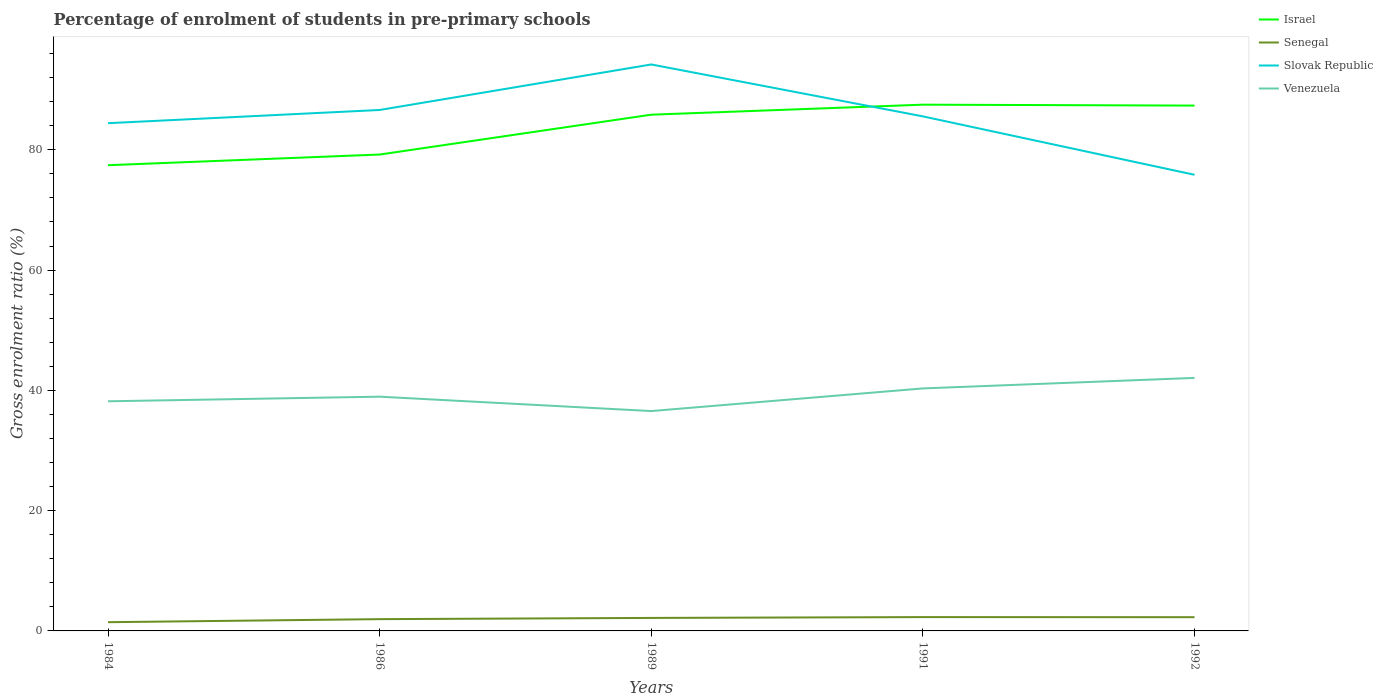How many different coloured lines are there?
Your answer should be very brief. 4. Does the line corresponding to Venezuela intersect with the line corresponding to Slovak Republic?
Offer a terse response. No. Across all years, what is the maximum percentage of students enrolled in pre-primary schools in Israel?
Offer a terse response. 77.43. What is the total percentage of students enrolled in pre-primary schools in Slovak Republic in the graph?
Give a very brief answer. 1.07. What is the difference between the highest and the second highest percentage of students enrolled in pre-primary schools in Venezuela?
Give a very brief answer. 5.51. What is the difference between the highest and the lowest percentage of students enrolled in pre-primary schools in Israel?
Keep it short and to the point. 3. Is the percentage of students enrolled in pre-primary schools in Slovak Republic strictly greater than the percentage of students enrolled in pre-primary schools in Venezuela over the years?
Offer a terse response. No. What is the difference between two consecutive major ticks on the Y-axis?
Provide a short and direct response. 20. Does the graph contain any zero values?
Keep it short and to the point. No. Where does the legend appear in the graph?
Keep it short and to the point. Top right. How many legend labels are there?
Your answer should be very brief. 4. What is the title of the graph?
Keep it short and to the point. Percentage of enrolment of students in pre-primary schools. What is the label or title of the Y-axis?
Ensure brevity in your answer.  Gross enrolment ratio (%). What is the Gross enrolment ratio (%) in Israel in 1984?
Offer a terse response. 77.43. What is the Gross enrolment ratio (%) of Senegal in 1984?
Your answer should be compact. 1.45. What is the Gross enrolment ratio (%) of Slovak Republic in 1984?
Offer a very short reply. 84.42. What is the Gross enrolment ratio (%) in Venezuela in 1984?
Make the answer very short. 38.18. What is the Gross enrolment ratio (%) in Israel in 1986?
Ensure brevity in your answer.  79.21. What is the Gross enrolment ratio (%) of Senegal in 1986?
Offer a very short reply. 1.96. What is the Gross enrolment ratio (%) of Slovak Republic in 1986?
Keep it short and to the point. 86.62. What is the Gross enrolment ratio (%) in Venezuela in 1986?
Offer a terse response. 38.95. What is the Gross enrolment ratio (%) of Israel in 1989?
Give a very brief answer. 85.83. What is the Gross enrolment ratio (%) in Senegal in 1989?
Offer a terse response. 2.16. What is the Gross enrolment ratio (%) of Slovak Republic in 1989?
Keep it short and to the point. 94.18. What is the Gross enrolment ratio (%) in Venezuela in 1989?
Keep it short and to the point. 36.56. What is the Gross enrolment ratio (%) in Israel in 1991?
Keep it short and to the point. 87.5. What is the Gross enrolment ratio (%) of Senegal in 1991?
Provide a succinct answer. 2.3. What is the Gross enrolment ratio (%) of Slovak Republic in 1991?
Provide a succinct answer. 85.55. What is the Gross enrolment ratio (%) in Venezuela in 1991?
Your answer should be compact. 40.32. What is the Gross enrolment ratio (%) of Israel in 1992?
Your answer should be compact. 87.35. What is the Gross enrolment ratio (%) in Senegal in 1992?
Ensure brevity in your answer.  2.28. What is the Gross enrolment ratio (%) of Slovak Republic in 1992?
Make the answer very short. 75.84. What is the Gross enrolment ratio (%) of Venezuela in 1992?
Offer a very short reply. 42.07. Across all years, what is the maximum Gross enrolment ratio (%) in Israel?
Offer a terse response. 87.5. Across all years, what is the maximum Gross enrolment ratio (%) in Senegal?
Make the answer very short. 2.3. Across all years, what is the maximum Gross enrolment ratio (%) in Slovak Republic?
Offer a terse response. 94.18. Across all years, what is the maximum Gross enrolment ratio (%) in Venezuela?
Make the answer very short. 42.07. Across all years, what is the minimum Gross enrolment ratio (%) in Israel?
Provide a succinct answer. 77.43. Across all years, what is the minimum Gross enrolment ratio (%) of Senegal?
Your response must be concise. 1.45. Across all years, what is the minimum Gross enrolment ratio (%) in Slovak Republic?
Your response must be concise. 75.84. Across all years, what is the minimum Gross enrolment ratio (%) in Venezuela?
Your answer should be very brief. 36.56. What is the total Gross enrolment ratio (%) of Israel in the graph?
Ensure brevity in your answer.  417.32. What is the total Gross enrolment ratio (%) of Senegal in the graph?
Your answer should be very brief. 10.15. What is the total Gross enrolment ratio (%) of Slovak Republic in the graph?
Your answer should be compact. 426.62. What is the total Gross enrolment ratio (%) in Venezuela in the graph?
Your answer should be very brief. 196.07. What is the difference between the Gross enrolment ratio (%) in Israel in 1984 and that in 1986?
Your answer should be very brief. -1.77. What is the difference between the Gross enrolment ratio (%) in Senegal in 1984 and that in 1986?
Offer a terse response. -0.51. What is the difference between the Gross enrolment ratio (%) in Slovak Republic in 1984 and that in 1986?
Offer a very short reply. -2.2. What is the difference between the Gross enrolment ratio (%) of Venezuela in 1984 and that in 1986?
Your response must be concise. -0.77. What is the difference between the Gross enrolment ratio (%) in Israel in 1984 and that in 1989?
Give a very brief answer. -8.4. What is the difference between the Gross enrolment ratio (%) in Senegal in 1984 and that in 1989?
Ensure brevity in your answer.  -0.71. What is the difference between the Gross enrolment ratio (%) of Slovak Republic in 1984 and that in 1989?
Offer a terse response. -9.76. What is the difference between the Gross enrolment ratio (%) in Venezuela in 1984 and that in 1989?
Provide a succinct answer. 1.62. What is the difference between the Gross enrolment ratio (%) of Israel in 1984 and that in 1991?
Offer a very short reply. -10.06. What is the difference between the Gross enrolment ratio (%) in Senegal in 1984 and that in 1991?
Make the answer very short. -0.85. What is the difference between the Gross enrolment ratio (%) of Slovak Republic in 1984 and that in 1991?
Offer a very short reply. -1.13. What is the difference between the Gross enrolment ratio (%) of Venezuela in 1984 and that in 1991?
Offer a very short reply. -2.14. What is the difference between the Gross enrolment ratio (%) of Israel in 1984 and that in 1992?
Keep it short and to the point. -9.91. What is the difference between the Gross enrolment ratio (%) of Senegal in 1984 and that in 1992?
Ensure brevity in your answer.  -0.83. What is the difference between the Gross enrolment ratio (%) in Slovak Republic in 1984 and that in 1992?
Make the answer very short. 8.58. What is the difference between the Gross enrolment ratio (%) of Venezuela in 1984 and that in 1992?
Give a very brief answer. -3.89. What is the difference between the Gross enrolment ratio (%) in Israel in 1986 and that in 1989?
Your answer should be very brief. -6.63. What is the difference between the Gross enrolment ratio (%) in Senegal in 1986 and that in 1989?
Keep it short and to the point. -0.2. What is the difference between the Gross enrolment ratio (%) of Slovak Republic in 1986 and that in 1989?
Provide a succinct answer. -7.57. What is the difference between the Gross enrolment ratio (%) of Venezuela in 1986 and that in 1989?
Make the answer very short. 2.39. What is the difference between the Gross enrolment ratio (%) in Israel in 1986 and that in 1991?
Your answer should be very brief. -8.29. What is the difference between the Gross enrolment ratio (%) in Senegal in 1986 and that in 1991?
Make the answer very short. -0.34. What is the difference between the Gross enrolment ratio (%) in Slovak Republic in 1986 and that in 1991?
Provide a short and direct response. 1.07. What is the difference between the Gross enrolment ratio (%) of Venezuela in 1986 and that in 1991?
Your answer should be compact. -1.37. What is the difference between the Gross enrolment ratio (%) in Israel in 1986 and that in 1992?
Provide a succinct answer. -8.14. What is the difference between the Gross enrolment ratio (%) of Senegal in 1986 and that in 1992?
Make the answer very short. -0.32. What is the difference between the Gross enrolment ratio (%) of Slovak Republic in 1986 and that in 1992?
Offer a very short reply. 10.78. What is the difference between the Gross enrolment ratio (%) of Venezuela in 1986 and that in 1992?
Provide a succinct answer. -3.12. What is the difference between the Gross enrolment ratio (%) in Israel in 1989 and that in 1991?
Provide a short and direct response. -1.66. What is the difference between the Gross enrolment ratio (%) in Senegal in 1989 and that in 1991?
Your response must be concise. -0.14. What is the difference between the Gross enrolment ratio (%) of Slovak Republic in 1989 and that in 1991?
Make the answer very short. 8.63. What is the difference between the Gross enrolment ratio (%) in Venezuela in 1989 and that in 1991?
Your answer should be very brief. -3.76. What is the difference between the Gross enrolment ratio (%) in Israel in 1989 and that in 1992?
Your answer should be very brief. -1.51. What is the difference between the Gross enrolment ratio (%) in Senegal in 1989 and that in 1992?
Your answer should be compact. -0.12. What is the difference between the Gross enrolment ratio (%) of Slovak Republic in 1989 and that in 1992?
Give a very brief answer. 18.34. What is the difference between the Gross enrolment ratio (%) of Venezuela in 1989 and that in 1992?
Ensure brevity in your answer.  -5.51. What is the difference between the Gross enrolment ratio (%) in Israel in 1991 and that in 1992?
Your answer should be very brief. 0.15. What is the difference between the Gross enrolment ratio (%) in Senegal in 1991 and that in 1992?
Give a very brief answer. 0.02. What is the difference between the Gross enrolment ratio (%) in Slovak Republic in 1991 and that in 1992?
Make the answer very short. 9.71. What is the difference between the Gross enrolment ratio (%) in Venezuela in 1991 and that in 1992?
Your response must be concise. -1.75. What is the difference between the Gross enrolment ratio (%) of Israel in 1984 and the Gross enrolment ratio (%) of Senegal in 1986?
Offer a very short reply. 75.48. What is the difference between the Gross enrolment ratio (%) in Israel in 1984 and the Gross enrolment ratio (%) in Slovak Republic in 1986?
Your answer should be very brief. -9.19. What is the difference between the Gross enrolment ratio (%) of Israel in 1984 and the Gross enrolment ratio (%) of Venezuela in 1986?
Provide a succinct answer. 38.49. What is the difference between the Gross enrolment ratio (%) of Senegal in 1984 and the Gross enrolment ratio (%) of Slovak Republic in 1986?
Offer a very short reply. -85.17. What is the difference between the Gross enrolment ratio (%) in Senegal in 1984 and the Gross enrolment ratio (%) in Venezuela in 1986?
Offer a terse response. -37.5. What is the difference between the Gross enrolment ratio (%) of Slovak Republic in 1984 and the Gross enrolment ratio (%) of Venezuela in 1986?
Offer a terse response. 45.47. What is the difference between the Gross enrolment ratio (%) of Israel in 1984 and the Gross enrolment ratio (%) of Senegal in 1989?
Your response must be concise. 75.27. What is the difference between the Gross enrolment ratio (%) of Israel in 1984 and the Gross enrolment ratio (%) of Slovak Republic in 1989?
Give a very brief answer. -16.75. What is the difference between the Gross enrolment ratio (%) of Israel in 1984 and the Gross enrolment ratio (%) of Venezuela in 1989?
Provide a short and direct response. 40.88. What is the difference between the Gross enrolment ratio (%) of Senegal in 1984 and the Gross enrolment ratio (%) of Slovak Republic in 1989?
Provide a succinct answer. -92.73. What is the difference between the Gross enrolment ratio (%) of Senegal in 1984 and the Gross enrolment ratio (%) of Venezuela in 1989?
Your response must be concise. -35.1. What is the difference between the Gross enrolment ratio (%) in Slovak Republic in 1984 and the Gross enrolment ratio (%) in Venezuela in 1989?
Provide a short and direct response. 47.86. What is the difference between the Gross enrolment ratio (%) of Israel in 1984 and the Gross enrolment ratio (%) of Senegal in 1991?
Your answer should be very brief. 75.13. What is the difference between the Gross enrolment ratio (%) in Israel in 1984 and the Gross enrolment ratio (%) in Slovak Republic in 1991?
Your answer should be compact. -8.12. What is the difference between the Gross enrolment ratio (%) in Israel in 1984 and the Gross enrolment ratio (%) in Venezuela in 1991?
Keep it short and to the point. 37.11. What is the difference between the Gross enrolment ratio (%) of Senegal in 1984 and the Gross enrolment ratio (%) of Slovak Republic in 1991?
Provide a short and direct response. -84.1. What is the difference between the Gross enrolment ratio (%) of Senegal in 1984 and the Gross enrolment ratio (%) of Venezuela in 1991?
Provide a succinct answer. -38.87. What is the difference between the Gross enrolment ratio (%) in Slovak Republic in 1984 and the Gross enrolment ratio (%) in Venezuela in 1991?
Your answer should be very brief. 44.1. What is the difference between the Gross enrolment ratio (%) in Israel in 1984 and the Gross enrolment ratio (%) in Senegal in 1992?
Your response must be concise. 75.15. What is the difference between the Gross enrolment ratio (%) in Israel in 1984 and the Gross enrolment ratio (%) in Slovak Republic in 1992?
Provide a succinct answer. 1.59. What is the difference between the Gross enrolment ratio (%) of Israel in 1984 and the Gross enrolment ratio (%) of Venezuela in 1992?
Ensure brevity in your answer.  35.37. What is the difference between the Gross enrolment ratio (%) of Senegal in 1984 and the Gross enrolment ratio (%) of Slovak Republic in 1992?
Offer a very short reply. -74.39. What is the difference between the Gross enrolment ratio (%) in Senegal in 1984 and the Gross enrolment ratio (%) in Venezuela in 1992?
Offer a very short reply. -40.62. What is the difference between the Gross enrolment ratio (%) of Slovak Republic in 1984 and the Gross enrolment ratio (%) of Venezuela in 1992?
Your answer should be very brief. 42.35. What is the difference between the Gross enrolment ratio (%) of Israel in 1986 and the Gross enrolment ratio (%) of Senegal in 1989?
Make the answer very short. 77.05. What is the difference between the Gross enrolment ratio (%) of Israel in 1986 and the Gross enrolment ratio (%) of Slovak Republic in 1989?
Offer a very short reply. -14.98. What is the difference between the Gross enrolment ratio (%) in Israel in 1986 and the Gross enrolment ratio (%) in Venezuela in 1989?
Make the answer very short. 42.65. What is the difference between the Gross enrolment ratio (%) of Senegal in 1986 and the Gross enrolment ratio (%) of Slovak Republic in 1989?
Make the answer very short. -92.23. What is the difference between the Gross enrolment ratio (%) of Senegal in 1986 and the Gross enrolment ratio (%) of Venezuela in 1989?
Your answer should be very brief. -34.6. What is the difference between the Gross enrolment ratio (%) of Slovak Republic in 1986 and the Gross enrolment ratio (%) of Venezuela in 1989?
Ensure brevity in your answer.  50.06. What is the difference between the Gross enrolment ratio (%) in Israel in 1986 and the Gross enrolment ratio (%) in Senegal in 1991?
Give a very brief answer. 76.91. What is the difference between the Gross enrolment ratio (%) of Israel in 1986 and the Gross enrolment ratio (%) of Slovak Republic in 1991?
Give a very brief answer. -6.34. What is the difference between the Gross enrolment ratio (%) of Israel in 1986 and the Gross enrolment ratio (%) of Venezuela in 1991?
Your answer should be compact. 38.89. What is the difference between the Gross enrolment ratio (%) in Senegal in 1986 and the Gross enrolment ratio (%) in Slovak Republic in 1991?
Your answer should be very brief. -83.59. What is the difference between the Gross enrolment ratio (%) in Senegal in 1986 and the Gross enrolment ratio (%) in Venezuela in 1991?
Offer a very short reply. -38.36. What is the difference between the Gross enrolment ratio (%) of Slovak Republic in 1986 and the Gross enrolment ratio (%) of Venezuela in 1991?
Make the answer very short. 46.3. What is the difference between the Gross enrolment ratio (%) in Israel in 1986 and the Gross enrolment ratio (%) in Senegal in 1992?
Offer a very short reply. 76.93. What is the difference between the Gross enrolment ratio (%) of Israel in 1986 and the Gross enrolment ratio (%) of Slovak Republic in 1992?
Keep it short and to the point. 3.37. What is the difference between the Gross enrolment ratio (%) of Israel in 1986 and the Gross enrolment ratio (%) of Venezuela in 1992?
Offer a very short reply. 37.14. What is the difference between the Gross enrolment ratio (%) of Senegal in 1986 and the Gross enrolment ratio (%) of Slovak Republic in 1992?
Your response must be concise. -73.88. What is the difference between the Gross enrolment ratio (%) in Senegal in 1986 and the Gross enrolment ratio (%) in Venezuela in 1992?
Provide a short and direct response. -40.11. What is the difference between the Gross enrolment ratio (%) in Slovak Republic in 1986 and the Gross enrolment ratio (%) in Venezuela in 1992?
Provide a succinct answer. 44.55. What is the difference between the Gross enrolment ratio (%) in Israel in 1989 and the Gross enrolment ratio (%) in Senegal in 1991?
Give a very brief answer. 83.54. What is the difference between the Gross enrolment ratio (%) in Israel in 1989 and the Gross enrolment ratio (%) in Slovak Republic in 1991?
Ensure brevity in your answer.  0.28. What is the difference between the Gross enrolment ratio (%) in Israel in 1989 and the Gross enrolment ratio (%) in Venezuela in 1991?
Keep it short and to the point. 45.51. What is the difference between the Gross enrolment ratio (%) in Senegal in 1989 and the Gross enrolment ratio (%) in Slovak Republic in 1991?
Provide a succinct answer. -83.39. What is the difference between the Gross enrolment ratio (%) in Senegal in 1989 and the Gross enrolment ratio (%) in Venezuela in 1991?
Your response must be concise. -38.16. What is the difference between the Gross enrolment ratio (%) in Slovak Republic in 1989 and the Gross enrolment ratio (%) in Venezuela in 1991?
Keep it short and to the point. 53.86. What is the difference between the Gross enrolment ratio (%) in Israel in 1989 and the Gross enrolment ratio (%) in Senegal in 1992?
Ensure brevity in your answer.  83.55. What is the difference between the Gross enrolment ratio (%) in Israel in 1989 and the Gross enrolment ratio (%) in Slovak Republic in 1992?
Offer a very short reply. 9.99. What is the difference between the Gross enrolment ratio (%) of Israel in 1989 and the Gross enrolment ratio (%) of Venezuela in 1992?
Ensure brevity in your answer.  43.77. What is the difference between the Gross enrolment ratio (%) in Senegal in 1989 and the Gross enrolment ratio (%) in Slovak Republic in 1992?
Your response must be concise. -73.68. What is the difference between the Gross enrolment ratio (%) in Senegal in 1989 and the Gross enrolment ratio (%) in Venezuela in 1992?
Make the answer very short. -39.91. What is the difference between the Gross enrolment ratio (%) in Slovak Republic in 1989 and the Gross enrolment ratio (%) in Venezuela in 1992?
Give a very brief answer. 52.12. What is the difference between the Gross enrolment ratio (%) in Israel in 1991 and the Gross enrolment ratio (%) in Senegal in 1992?
Provide a succinct answer. 85.22. What is the difference between the Gross enrolment ratio (%) of Israel in 1991 and the Gross enrolment ratio (%) of Slovak Republic in 1992?
Provide a succinct answer. 11.66. What is the difference between the Gross enrolment ratio (%) in Israel in 1991 and the Gross enrolment ratio (%) in Venezuela in 1992?
Your answer should be compact. 45.43. What is the difference between the Gross enrolment ratio (%) in Senegal in 1991 and the Gross enrolment ratio (%) in Slovak Republic in 1992?
Make the answer very short. -73.54. What is the difference between the Gross enrolment ratio (%) in Senegal in 1991 and the Gross enrolment ratio (%) in Venezuela in 1992?
Ensure brevity in your answer.  -39.77. What is the difference between the Gross enrolment ratio (%) of Slovak Republic in 1991 and the Gross enrolment ratio (%) of Venezuela in 1992?
Ensure brevity in your answer.  43.48. What is the average Gross enrolment ratio (%) in Israel per year?
Your answer should be compact. 83.46. What is the average Gross enrolment ratio (%) of Senegal per year?
Provide a short and direct response. 2.03. What is the average Gross enrolment ratio (%) of Slovak Republic per year?
Your answer should be compact. 85.32. What is the average Gross enrolment ratio (%) in Venezuela per year?
Offer a terse response. 39.21. In the year 1984, what is the difference between the Gross enrolment ratio (%) of Israel and Gross enrolment ratio (%) of Senegal?
Provide a succinct answer. 75.98. In the year 1984, what is the difference between the Gross enrolment ratio (%) in Israel and Gross enrolment ratio (%) in Slovak Republic?
Your answer should be compact. -6.99. In the year 1984, what is the difference between the Gross enrolment ratio (%) in Israel and Gross enrolment ratio (%) in Venezuela?
Provide a succinct answer. 39.25. In the year 1984, what is the difference between the Gross enrolment ratio (%) of Senegal and Gross enrolment ratio (%) of Slovak Republic?
Offer a very short reply. -82.97. In the year 1984, what is the difference between the Gross enrolment ratio (%) of Senegal and Gross enrolment ratio (%) of Venezuela?
Ensure brevity in your answer.  -36.73. In the year 1984, what is the difference between the Gross enrolment ratio (%) in Slovak Republic and Gross enrolment ratio (%) in Venezuela?
Make the answer very short. 46.24. In the year 1986, what is the difference between the Gross enrolment ratio (%) in Israel and Gross enrolment ratio (%) in Senegal?
Give a very brief answer. 77.25. In the year 1986, what is the difference between the Gross enrolment ratio (%) in Israel and Gross enrolment ratio (%) in Slovak Republic?
Offer a terse response. -7.41. In the year 1986, what is the difference between the Gross enrolment ratio (%) of Israel and Gross enrolment ratio (%) of Venezuela?
Give a very brief answer. 40.26. In the year 1986, what is the difference between the Gross enrolment ratio (%) of Senegal and Gross enrolment ratio (%) of Slovak Republic?
Your response must be concise. -84.66. In the year 1986, what is the difference between the Gross enrolment ratio (%) in Senegal and Gross enrolment ratio (%) in Venezuela?
Provide a short and direct response. -36.99. In the year 1986, what is the difference between the Gross enrolment ratio (%) in Slovak Republic and Gross enrolment ratio (%) in Venezuela?
Offer a terse response. 47.67. In the year 1989, what is the difference between the Gross enrolment ratio (%) of Israel and Gross enrolment ratio (%) of Senegal?
Provide a succinct answer. 83.67. In the year 1989, what is the difference between the Gross enrolment ratio (%) in Israel and Gross enrolment ratio (%) in Slovak Republic?
Give a very brief answer. -8.35. In the year 1989, what is the difference between the Gross enrolment ratio (%) in Israel and Gross enrolment ratio (%) in Venezuela?
Offer a terse response. 49.28. In the year 1989, what is the difference between the Gross enrolment ratio (%) in Senegal and Gross enrolment ratio (%) in Slovak Republic?
Your answer should be very brief. -92.02. In the year 1989, what is the difference between the Gross enrolment ratio (%) of Senegal and Gross enrolment ratio (%) of Venezuela?
Your answer should be compact. -34.4. In the year 1989, what is the difference between the Gross enrolment ratio (%) in Slovak Republic and Gross enrolment ratio (%) in Venezuela?
Ensure brevity in your answer.  57.63. In the year 1991, what is the difference between the Gross enrolment ratio (%) of Israel and Gross enrolment ratio (%) of Senegal?
Give a very brief answer. 85.2. In the year 1991, what is the difference between the Gross enrolment ratio (%) in Israel and Gross enrolment ratio (%) in Slovak Republic?
Your answer should be very brief. 1.95. In the year 1991, what is the difference between the Gross enrolment ratio (%) of Israel and Gross enrolment ratio (%) of Venezuela?
Keep it short and to the point. 47.18. In the year 1991, what is the difference between the Gross enrolment ratio (%) in Senegal and Gross enrolment ratio (%) in Slovak Republic?
Provide a short and direct response. -83.25. In the year 1991, what is the difference between the Gross enrolment ratio (%) in Senegal and Gross enrolment ratio (%) in Venezuela?
Your answer should be very brief. -38.02. In the year 1991, what is the difference between the Gross enrolment ratio (%) of Slovak Republic and Gross enrolment ratio (%) of Venezuela?
Keep it short and to the point. 45.23. In the year 1992, what is the difference between the Gross enrolment ratio (%) in Israel and Gross enrolment ratio (%) in Senegal?
Keep it short and to the point. 85.06. In the year 1992, what is the difference between the Gross enrolment ratio (%) of Israel and Gross enrolment ratio (%) of Slovak Republic?
Provide a succinct answer. 11.5. In the year 1992, what is the difference between the Gross enrolment ratio (%) of Israel and Gross enrolment ratio (%) of Venezuela?
Offer a terse response. 45.28. In the year 1992, what is the difference between the Gross enrolment ratio (%) in Senegal and Gross enrolment ratio (%) in Slovak Republic?
Your answer should be very brief. -73.56. In the year 1992, what is the difference between the Gross enrolment ratio (%) of Senegal and Gross enrolment ratio (%) of Venezuela?
Your response must be concise. -39.79. In the year 1992, what is the difference between the Gross enrolment ratio (%) of Slovak Republic and Gross enrolment ratio (%) of Venezuela?
Offer a terse response. 33.77. What is the ratio of the Gross enrolment ratio (%) in Israel in 1984 to that in 1986?
Your answer should be very brief. 0.98. What is the ratio of the Gross enrolment ratio (%) of Senegal in 1984 to that in 1986?
Give a very brief answer. 0.74. What is the ratio of the Gross enrolment ratio (%) in Slovak Republic in 1984 to that in 1986?
Make the answer very short. 0.97. What is the ratio of the Gross enrolment ratio (%) in Venezuela in 1984 to that in 1986?
Provide a short and direct response. 0.98. What is the ratio of the Gross enrolment ratio (%) of Israel in 1984 to that in 1989?
Your answer should be compact. 0.9. What is the ratio of the Gross enrolment ratio (%) of Senegal in 1984 to that in 1989?
Offer a terse response. 0.67. What is the ratio of the Gross enrolment ratio (%) of Slovak Republic in 1984 to that in 1989?
Ensure brevity in your answer.  0.9. What is the ratio of the Gross enrolment ratio (%) in Venezuela in 1984 to that in 1989?
Provide a short and direct response. 1.04. What is the ratio of the Gross enrolment ratio (%) of Israel in 1984 to that in 1991?
Offer a terse response. 0.89. What is the ratio of the Gross enrolment ratio (%) in Senegal in 1984 to that in 1991?
Provide a succinct answer. 0.63. What is the ratio of the Gross enrolment ratio (%) of Venezuela in 1984 to that in 1991?
Provide a succinct answer. 0.95. What is the ratio of the Gross enrolment ratio (%) in Israel in 1984 to that in 1992?
Make the answer very short. 0.89. What is the ratio of the Gross enrolment ratio (%) in Senegal in 1984 to that in 1992?
Offer a terse response. 0.64. What is the ratio of the Gross enrolment ratio (%) in Slovak Republic in 1984 to that in 1992?
Keep it short and to the point. 1.11. What is the ratio of the Gross enrolment ratio (%) in Venezuela in 1984 to that in 1992?
Your answer should be very brief. 0.91. What is the ratio of the Gross enrolment ratio (%) of Israel in 1986 to that in 1989?
Give a very brief answer. 0.92. What is the ratio of the Gross enrolment ratio (%) in Senegal in 1986 to that in 1989?
Provide a short and direct response. 0.91. What is the ratio of the Gross enrolment ratio (%) in Slovak Republic in 1986 to that in 1989?
Provide a short and direct response. 0.92. What is the ratio of the Gross enrolment ratio (%) in Venezuela in 1986 to that in 1989?
Your answer should be very brief. 1.07. What is the ratio of the Gross enrolment ratio (%) of Israel in 1986 to that in 1991?
Give a very brief answer. 0.91. What is the ratio of the Gross enrolment ratio (%) in Senegal in 1986 to that in 1991?
Offer a terse response. 0.85. What is the ratio of the Gross enrolment ratio (%) in Slovak Republic in 1986 to that in 1991?
Keep it short and to the point. 1.01. What is the ratio of the Gross enrolment ratio (%) in Israel in 1986 to that in 1992?
Make the answer very short. 0.91. What is the ratio of the Gross enrolment ratio (%) in Senegal in 1986 to that in 1992?
Your answer should be compact. 0.86. What is the ratio of the Gross enrolment ratio (%) of Slovak Republic in 1986 to that in 1992?
Make the answer very short. 1.14. What is the ratio of the Gross enrolment ratio (%) in Venezuela in 1986 to that in 1992?
Provide a short and direct response. 0.93. What is the ratio of the Gross enrolment ratio (%) of Senegal in 1989 to that in 1991?
Offer a terse response. 0.94. What is the ratio of the Gross enrolment ratio (%) in Slovak Republic in 1989 to that in 1991?
Ensure brevity in your answer.  1.1. What is the ratio of the Gross enrolment ratio (%) of Venezuela in 1989 to that in 1991?
Offer a terse response. 0.91. What is the ratio of the Gross enrolment ratio (%) in Israel in 1989 to that in 1992?
Make the answer very short. 0.98. What is the ratio of the Gross enrolment ratio (%) of Senegal in 1989 to that in 1992?
Your response must be concise. 0.95. What is the ratio of the Gross enrolment ratio (%) in Slovak Republic in 1989 to that in 1992?
Offer a terse response. 1.24. What is the ratio of the Gross enrolment ratio (%) in Venezuela in 1989 to that in 1992?
Provide a succinct answer. 0.87. What is the ratio of the Gross enrolment ratio (%) of Israel in 1991 to that in 1992?
Make the answer very short. 1. What is the ratio of the Gross enrolment ratio (%) in Senegal in 1991 to that in 1992?
Provide a short and direct response. 1.01. What is the ratio of the Gross enrolment ratio (%) in Slovak Republic in 1991 to that in 1992?
Give a very brief answer. 1.13. What is the ratio of the Gross enrolment ratio (%) of Venezuela in 1991 to that in 1992?
Make the answer very short. 0.96. What is the difference between the highest and the second highest Gross enrolment ratio (%) of Israel?
Your answer should be very brief. 0.15. What is the difference between the highest and the second highest Gross enrolment ratio (%) in Senegal?
Provide a succinct answer. 0.02. What is the difference between the highest and the second highest Gross enrolment ratio (%) in Slovak Republic?
Your response must be concise. 7.57. What is the difference between the highest and the second highest Gross enrolment ratio (%) in Venezuela?
Ensure brevity in your answer.  1.75. What is the difference between the highest and the lowest Gross enrolment ratio (%) in Israel?
Your response must be concise. 10.06. What is the difference between the highest and the lowest Gross enrolment ratio (%) in Senegal?
Give a very brief answer. 0.85. What is the difference between the highest and the lowest Gross enrolment ratio (%) of Slovak Republic?
Ensure brevity in your answer.  18.34. What is the difference between the highest and the lowest Gross enrolment ratio (%) of Venezuela?
Give a very brief answer. 5.51. 